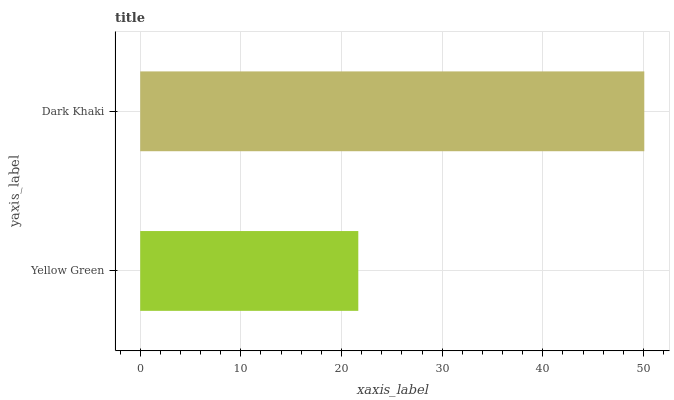Is Yellow Green the minimum?
Answer yes or no. Yes. Is Dark Khaki the maximum?
Answer yes or no. Yes. Is Dark Khaki the minimum?
Answer yes or no. No. Is Dark Khaki greater than Yellow Green?
Answer yes or no. Yes. Is Yellow Green less than Dark Khaki?
Answer yes or no. Yes. Is Yellow Green greater than Dark Khaki?
Answer yes or no. No. Is Dark Khaki less than Yellow Green?
Answer yes or no. No. Is Dark Khaki the high median?
Answer yes or no. Yes. Is Yellow Green the low median?
Answer yes or no. Yes. Is Yellow Green the high median?
Answer yes or no. No. Is Dark Khaki the low median?
Answer yes or no. No. 